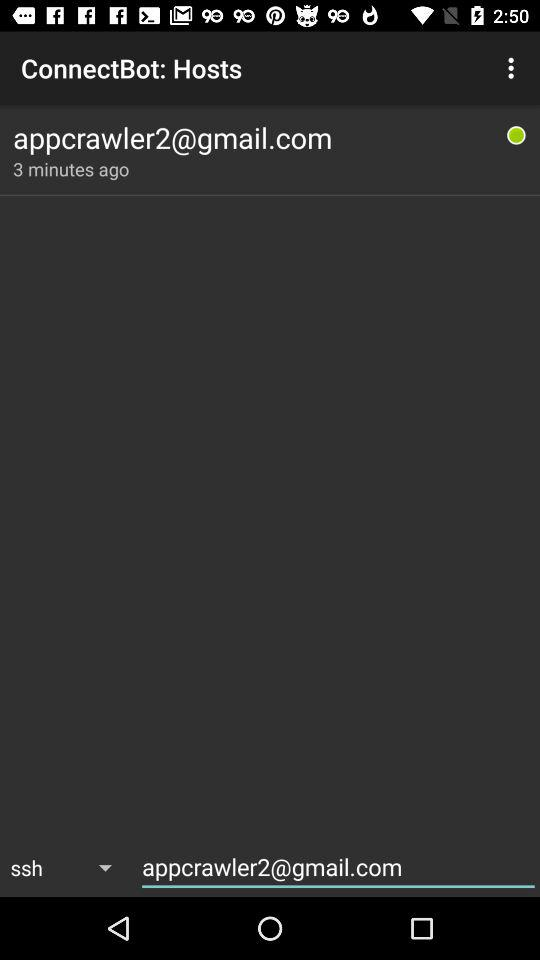How many minutes ago was the last connection?
Answer the question using a single word or phrase. 3 